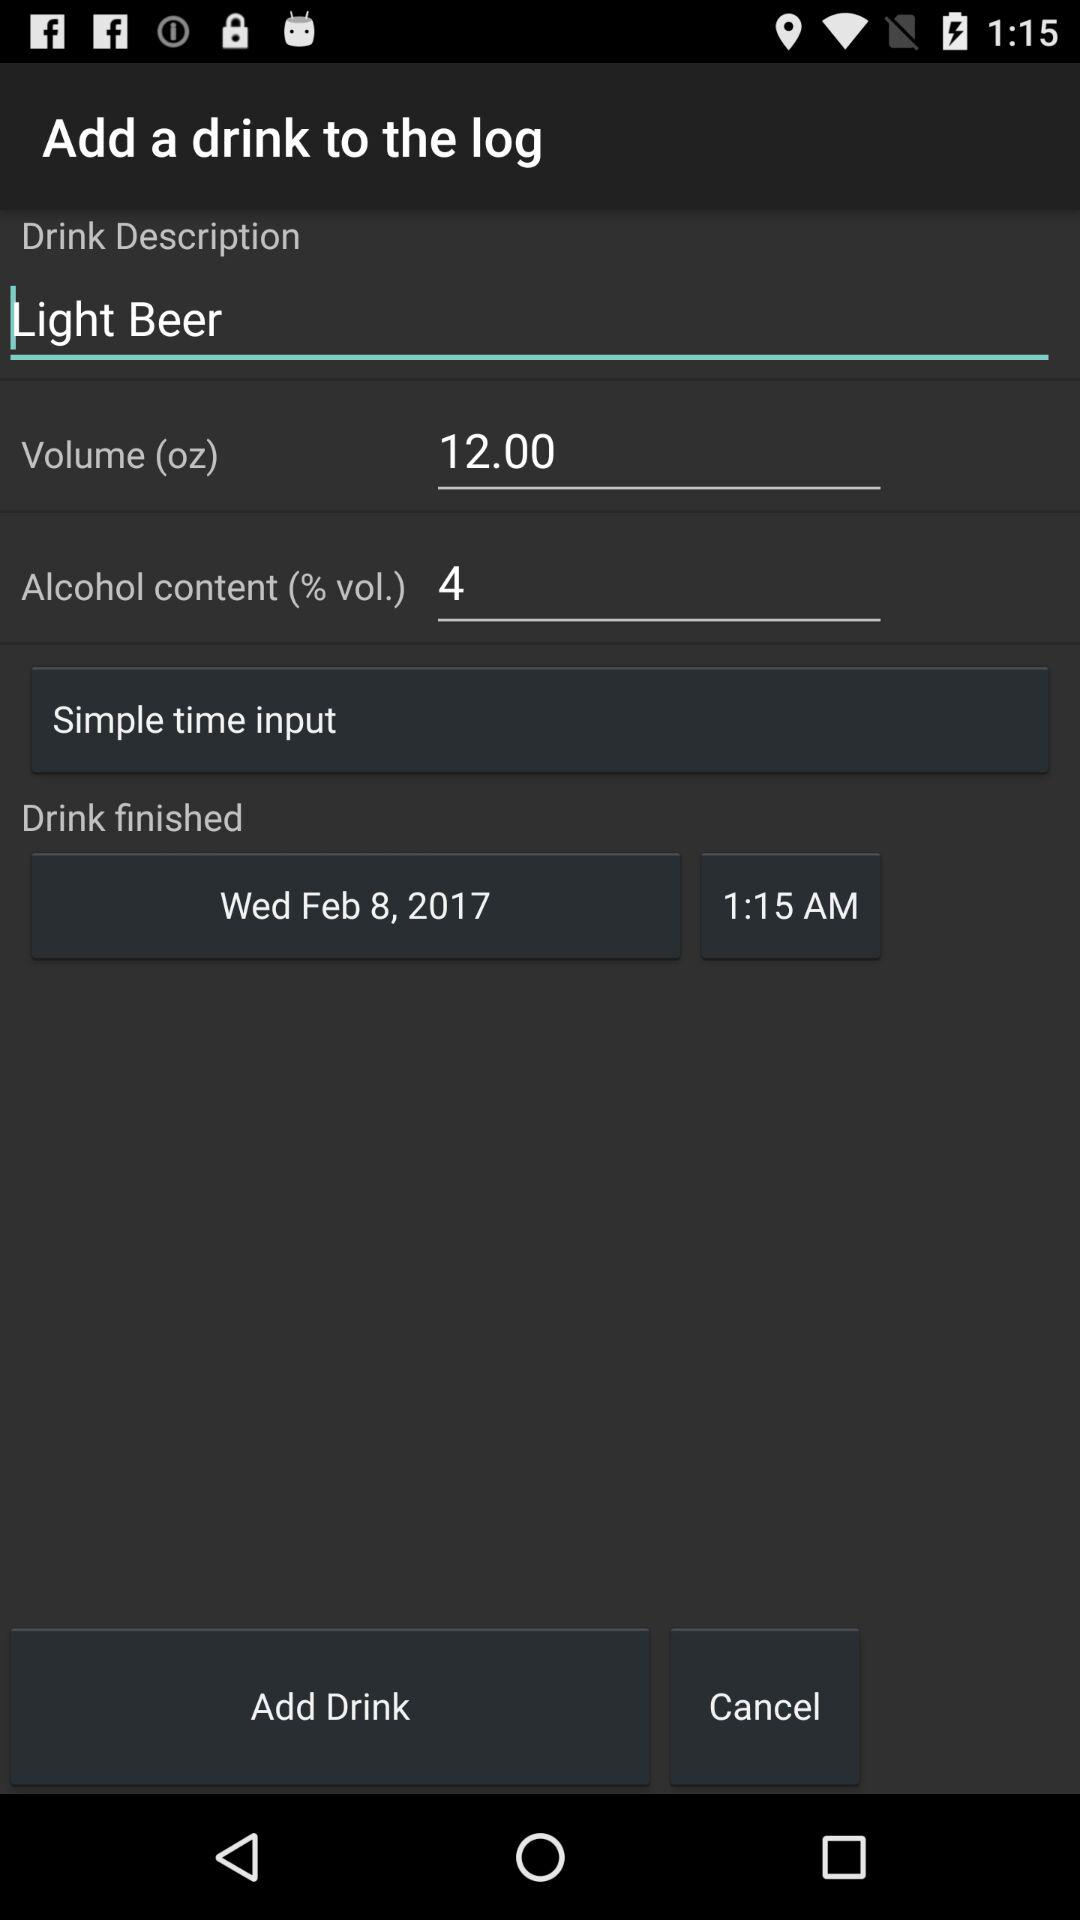When was the drink finished? The drink was finished on Wednesday, February 8, 2017 at 1:15 a.m. 